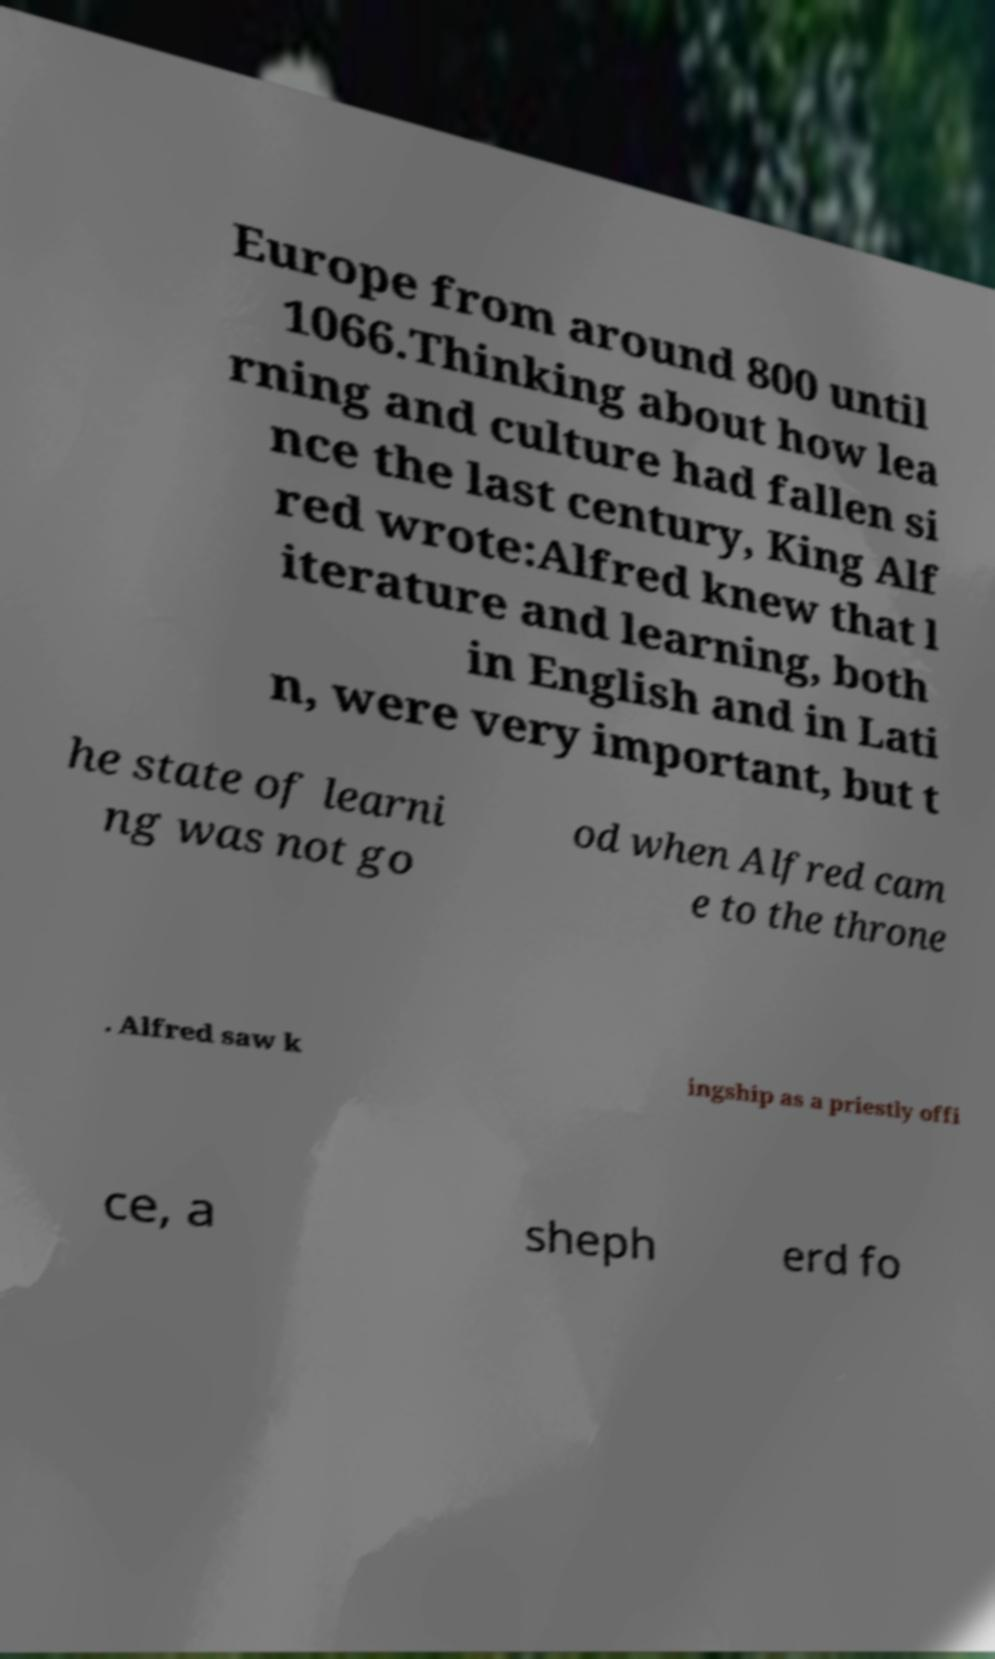I need the written content from this picture converted into text. Can you do that? Europe from around 800 until 1066.Thinking about how lea rning and culture had fallen si nce the last century, King Alf red wrote:Alfred knew that l iterature and learning, both in English and in Lati n, were very important, but t he state of learni ng was not go od when Alfred cam e to the throne . Alfred saw k ingship as a priestly offi ce, a sheph erd fo 